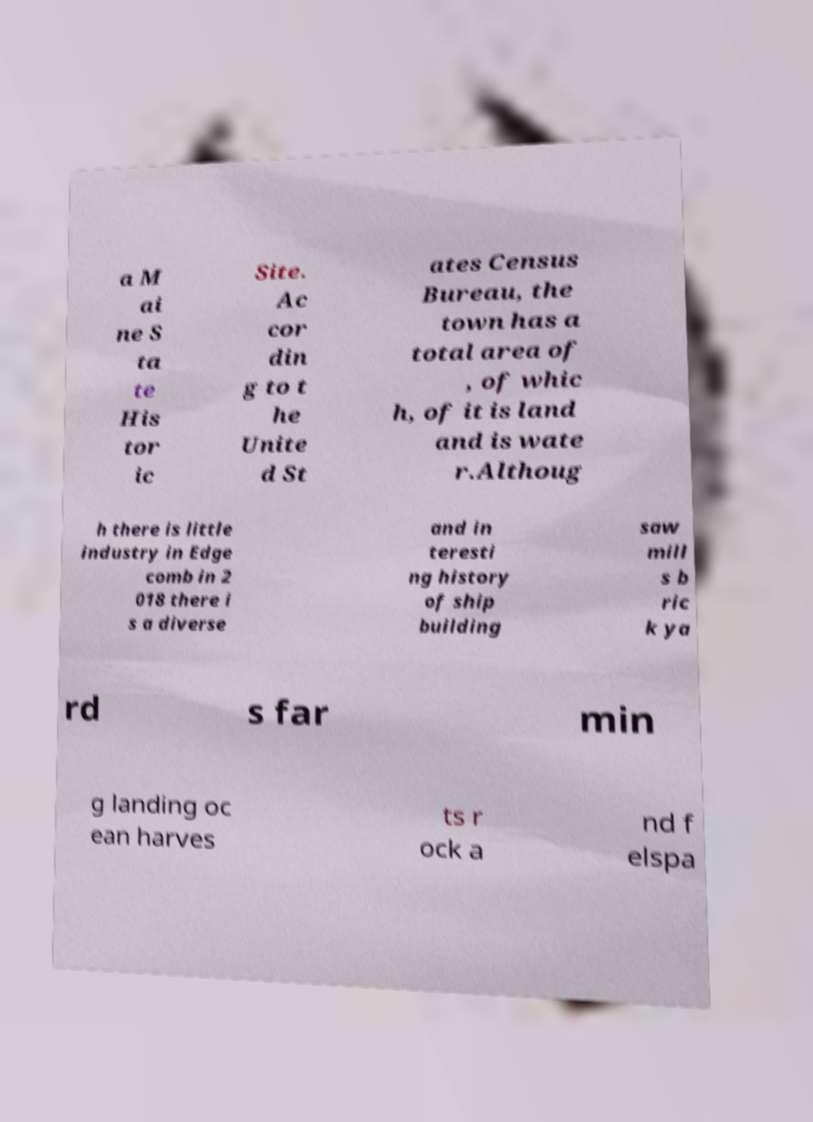For documentation purposes, I need the text within this image transcribed. Could you provide that? a M ai ne S ta te His tor ic Site. Ac cor din g to t he Unite d St ates Census Bureau, the town has a total area of , of whic h, of it is land and is wate r.Althoug h there is little industry in Edge comb in 2 018 there i s a diverse and in teresti ng history of ship building saw mill s b ric k ya rd s far min g landing oc ean harves ts r ock a nd f elspa 